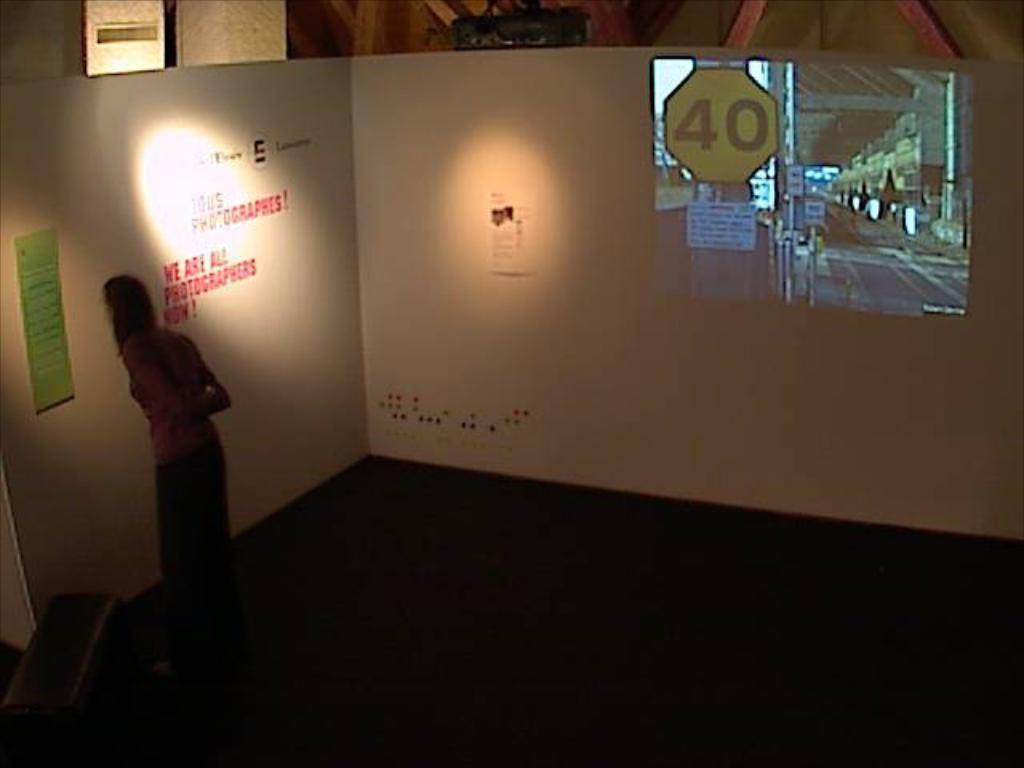Could you give a brief overview of what you see in this image? As we can see in the image there is a wall, poster, a woman over here and a mirror. 